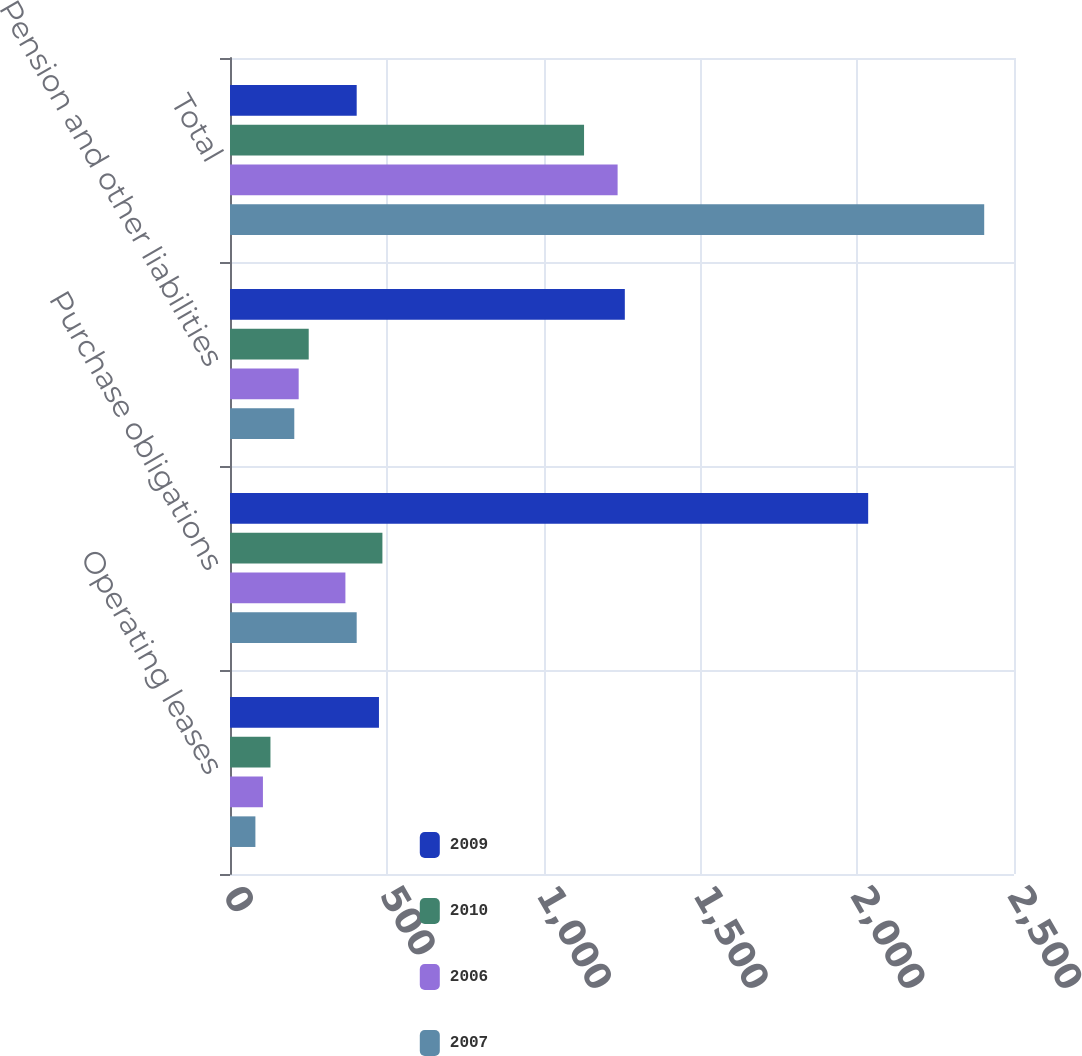Convert chart to OTSL. <chart><loc_0><loc_0><loc_500><loc_500><stacked_bar_chart><ecel><fcel>Operating leases<fcel>Purchase obligations<fcel>Pension and other liabilities<fcel>Total<nl><fcel>2009<fcel>475<fcel>2035<fcel>1259<fcel>404<nl><fcel>2010<fcel>129<fcel>486<fcel>251<fcel>1129<nl><fcel>2006<fcel>105<fcel>368<fcel>219<fcel>1236<nl><fcel>2007<fcel>81<fcel>404<fcel>205<fcel>2405<nl></chart> 